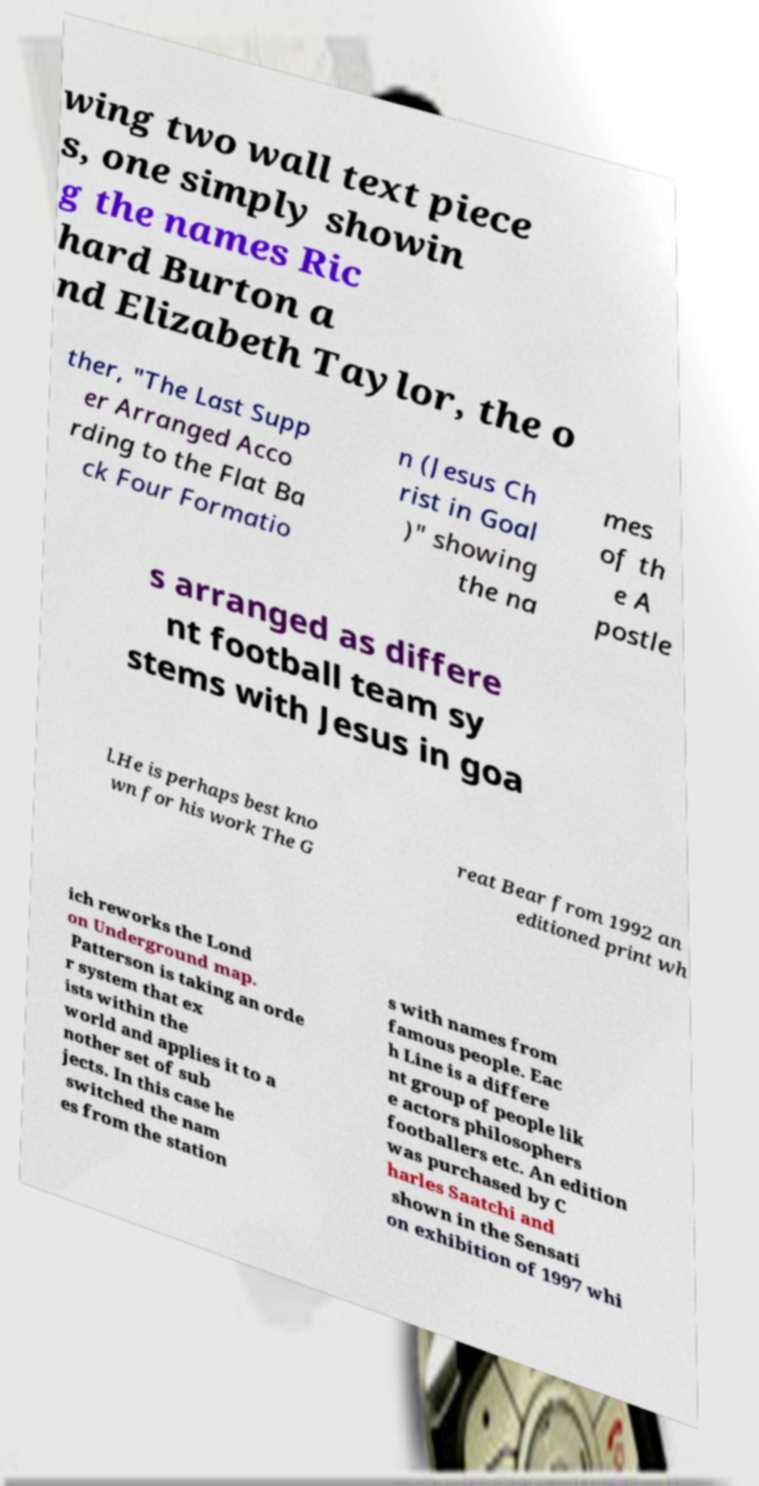Please read and relay the text visible in this image. What does it say? wing two wall text piece s, one simply showin g the names Ric hard Burton a nd Elizabeth Taylor, the o ther, "The Last Supp er Arranged Acco rding to the Flat Ba ck Four Formatio n (Jesus Ch rist in Goal )" showing the na mes of th e A postle s arranged as differe nt football team sy stems with Jesus in goa l.He is perhaps best kno wn for his work The G reat Bear from 1992 an editioned print wh ich reworks the Lond on Underground map. Patterson is taking an orde r system that ex ists within the world and applies it to a nother set of sub jects. In this case he switched the nam es from the station s with names from famous people. Eac h Line is a differe nt group of people lik e actors philosophers footballers etc. An edition was purchased by C harles Saatchi and shown in the Sensati on exhibition of 1997 whi 